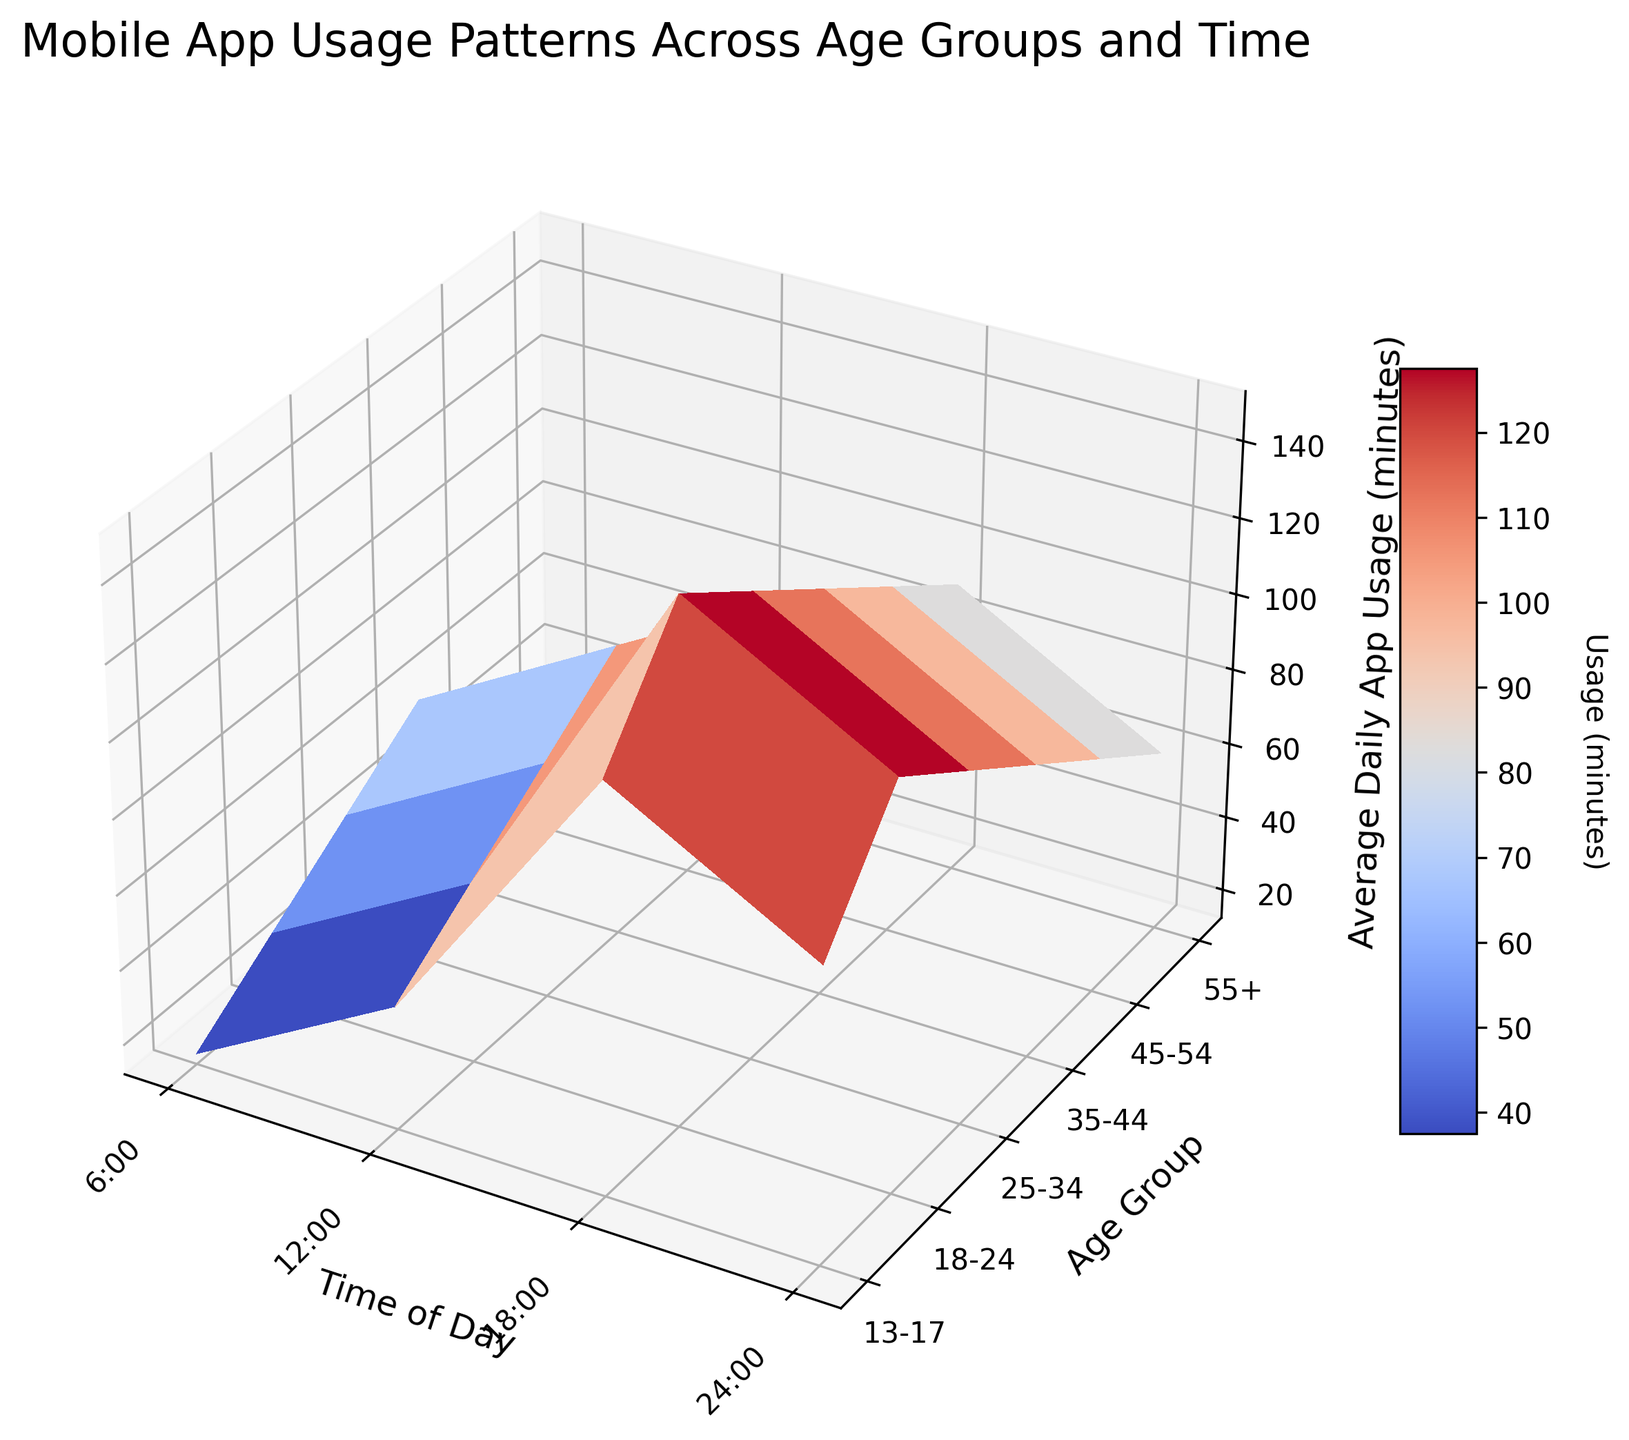What is the title of the figure? The title of the figure is usually found at the top of the plot. It provides a concise description of what the plot represents. In this case, it indicates "Mobile App Usage Patterns Across Age Groups and Time".
Answer: Mobile App Usage Patterns Across Age Groups and Time Which axis represents the age groups? In a 3D surface plot, each axis represents a different dimension of the data. The y-axis represents the age groups as labeled.
Answer: y-axis What color does the highest average daily app usage value correspond to? Colors on a 3D surface plot correlate with usage values. Generally, warmer colors like red represent higher values in the coolwarm colormap.
Answer: Red Which age group has the highest average app usage at 18:00? To find the highest value at 18:00, look at the vertical slice of the surface plot at the 18:00 time mark and identify the age group with the highest value there.
Answer: 18-24 What is the average daily app usage for the 25-34 age group at 6:00? Locate the point on the surface plot corresponding to the age group "25-34" and the time "6:00" and read the usage value.
Answer: 45 minutes During which time of day does the "13-17" age group use apps most? At each time of day, observe the height of the surface at the "13-17" age group. The highest point indicates the maximum usage.
Answer: 18:00 How does the average app usage change from 6:00 to 24:00 for the age group 45-54? Examine the height of the surface plot along the "45-54" row, observing the change from 6:00 to 24:00.
Answer: 45 → 75 → 105 → 75 Compare the average app usage between the 18-24 and 55+ age groups at 18:00. Identify the heights on the surface plot at 18:00 for both age groups and compare them.
Answer: 150 minutes for 18-24, 90 minutes for 55+ What is the trend of app usage for all age groups at 12:00? Analyze the height of the surface plot along the column representing 12:00 to observe the trend from youngest to oldest age groups.
Answer: Increasing Which age group has the smallest variation in app usage throughout the day? Look at the surface plot and compare the range of usage within each age group across different times of day. The age group with the flattest surface area has the smallest variation.
Answer: 55+ 